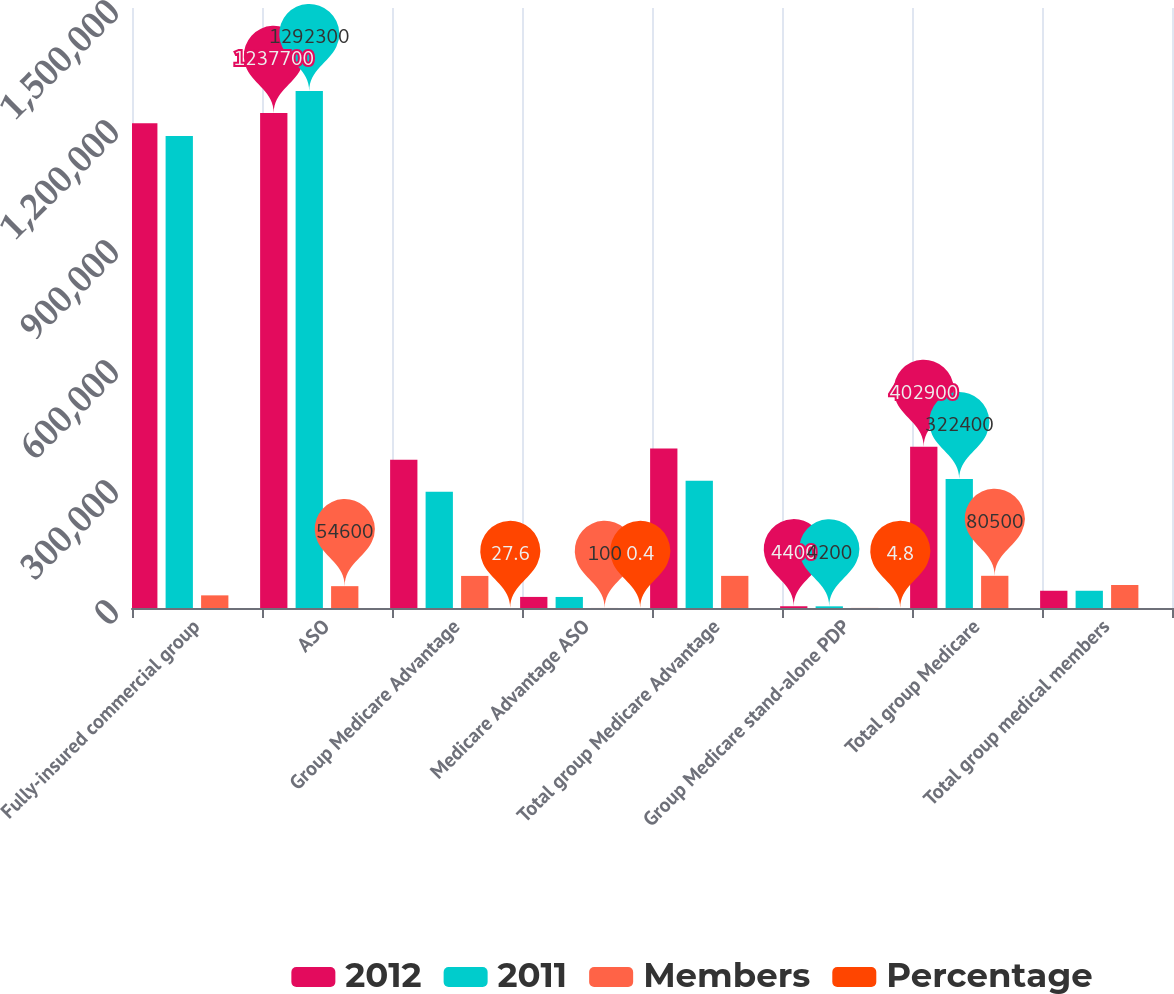Convert chart to OTSL. <chart><loc_0><loc_0><loc_500><loc_500><stacked_bar_chart><ecel><fcel>Fully-insured commercial group<fcel>ASO<fcel>Group Medicare Advantage<fcel>Medicare Advantage ASO<fcel>Total group Medicare Advantage<fcel>Group Medicare stand-alone PDP<fcel>Total group Medicare<fcel>Total group medical members<nl><fcel>2012<fcel>1.2118e+06<fcel>1.2377e+06<fcel>370800<fcel>27700<fcel>398500<fcel>4400<fcel>402900<fcel>43100<nl><fcel>2011<fcel>1.1802e+06<fcel>1.2923e+06<fcel>290600<fcel>27600<fcel>318200<fcel>4200<fcel>322400<fcel>43100<nl><fcel>Members<fcel>31600<fcel>54600<fcel>80200<fcel>100<fcel>80300<fcel>200<fcel>80500<fcel>57500<nl><fcel>Percentage<fcel>2.7<fcel>4.2<fcel>27.6<fcel>0.4<fcel>25.2<fcel>4.8<fcel>25<fcel>2.1<nl></chart> 